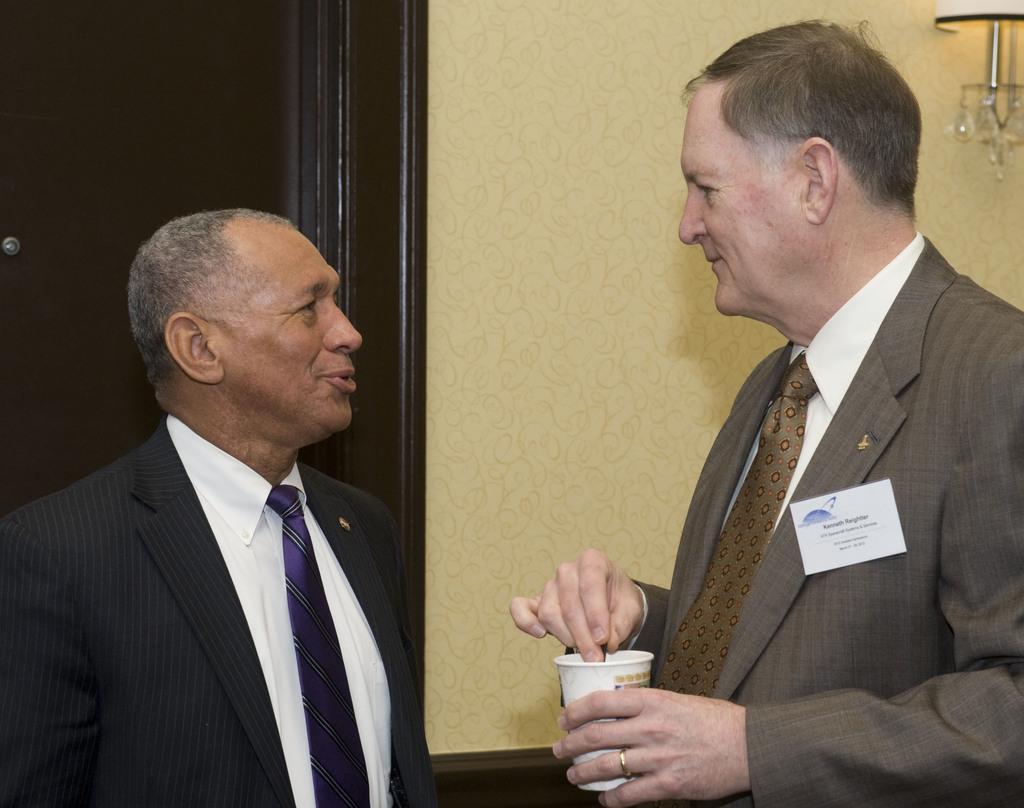Please provide a concise description of this image. In this image we can see two persons wearing black and grey color suit standing and discussing between themselves, person wearing grey color suit holding coffee glass in his hands and there is some badge attached to his suit and in the background of the image there is a wall and door which is black in color. 